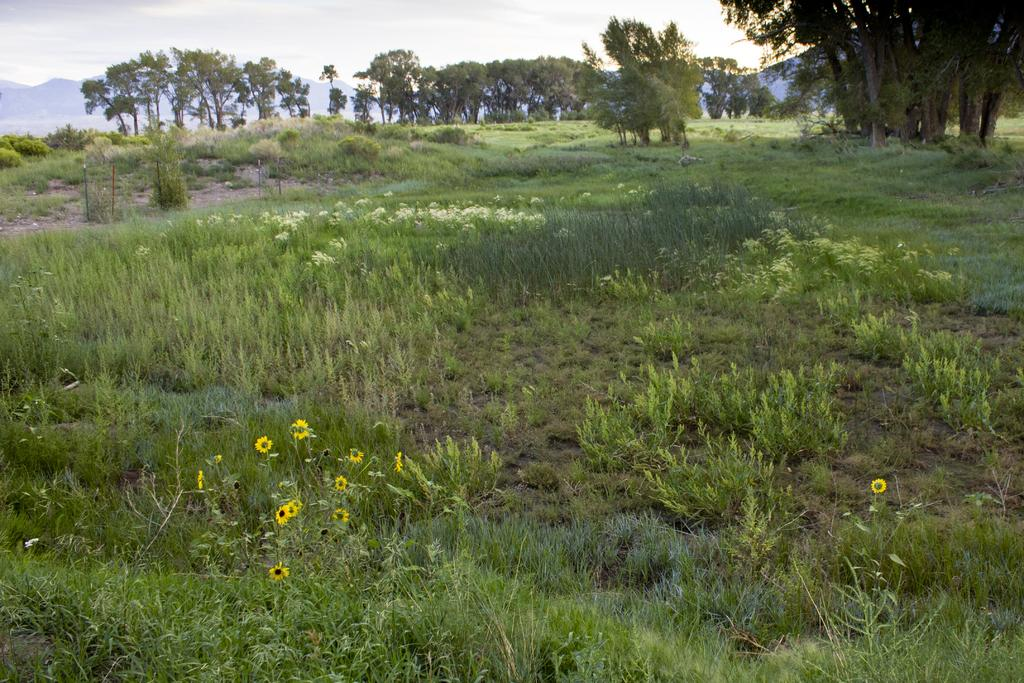What type of surface is visible in the image? There is a grass surface in the image. Are there any other plants visible besides the grass? Yes, there are flowering plants among the grass. What can be seen in the background of the image? There are many trees in the background of the image. What type of teaching is taking place in the image? There is no teaching activity present in the image; it features a grass surface with flowering plants and trees in the background. 